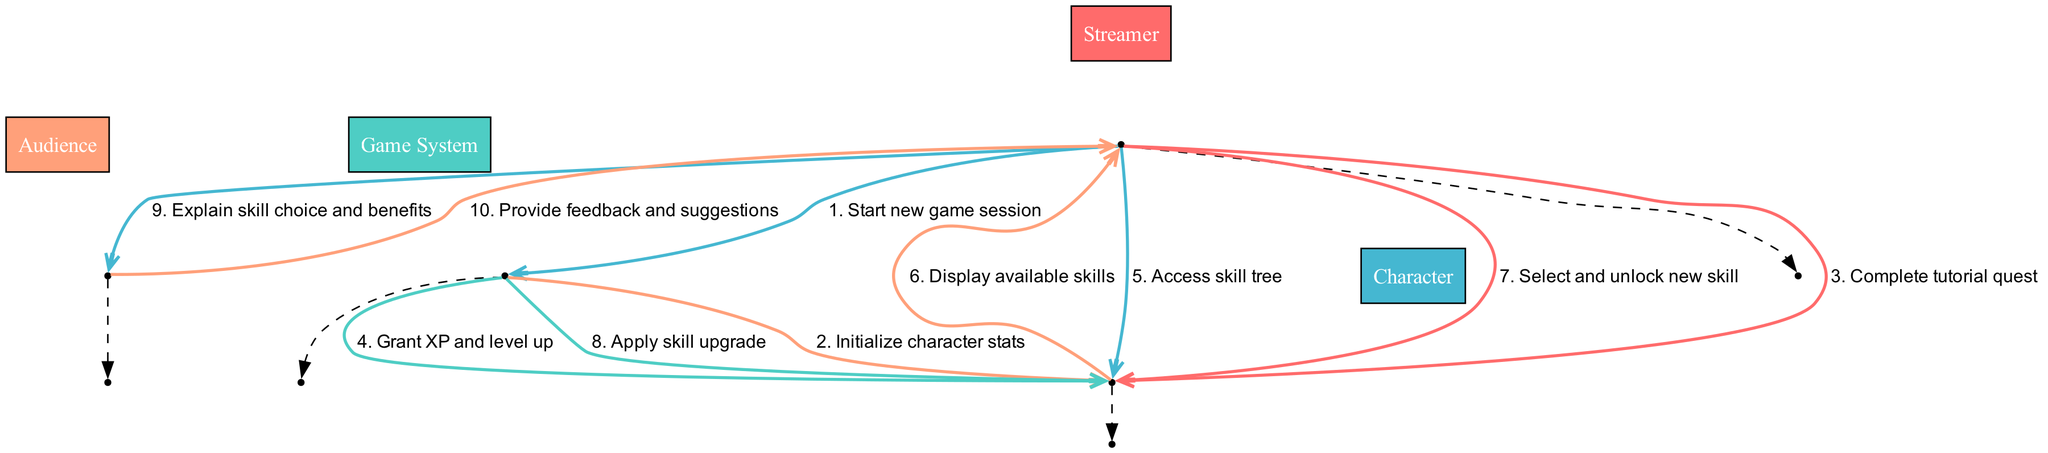What is the first action taken by the Streamer? The first action listed between the Streamer and the Game System is "Start new game session." This defines the starting point of the sequence for character progression.
Answer: Start new game session How many actions occur between the Game System and the Character? There are three direct actions between the Game System and the Character: "Initialize character stats," "Grant XP and level up," and "Apply skill upgrade." This total is derived from counting the relevant sequences in the diagram.
Answer: 3 What is the last action from the Streamer to the Audience? The last action from the Streamer to the Audience is "Explain skill choice and benefits." This highlights the communication at the end of the progression sequence.
Answer: Explain skill choice and benefits Which actor displays the available skills? The Character is responsible for displaying the available skills to the Streamer. This process is part of the skill tree interaction that follows character leveling.
Answer: Character What is the relationship between the Streamer and the Audience? The relationship includes two actions, where the Streamer explains skill choices and receives feedback and suggestions from the Audience. This reflects the interactive nature of streaming content.
Answer: Explain skill choice and benefits; Provide feedback and suggestions 